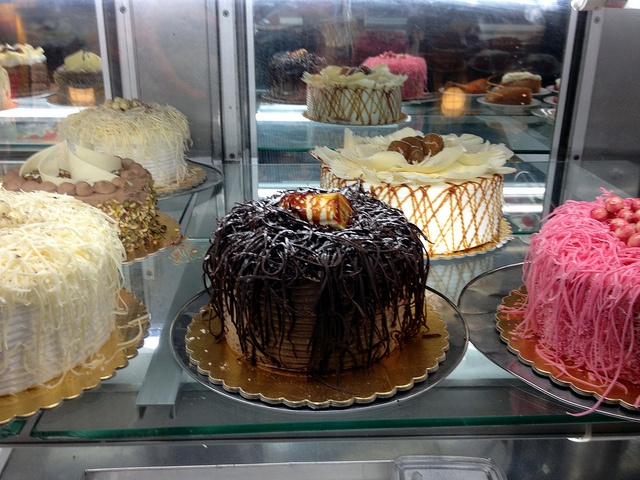Describe the objects in this image and their specific colors. I can see cake in gray, black, maroon, and darkgray tones, cake in gray, beige, and darkgray tones, cake in gray, brown, maroon, salmon, and lightpink tones, cake in gray, darkgray, tan, and ivory tones, and cake in gray and tan tones in this image. 